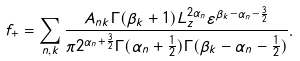Convert formula to latex. <formula><loc_0><loc_0><loc_500><loc_500>f _ { + } = \sum _ { n , k } \frac { A _ { n k } \Gamma ( \beta _ { k } + 1 ) L _ { z } ^ { 2 \alpha _ { n } } \varepsilon ^ { \beta _ { k } - \alpha _ { n } - \frac { 3 } { 2 } } } { \pi 2 ^ { \alpha _ { n } + \frac { 3 } { 2 } } \Gamma ( \alpha _ { n } + \frac { 1 } { 2 } ) \Gamma ( \beta _ { k } - \alpha _ { n } - \frac { 1 } { 2 } ) } .</formula> 